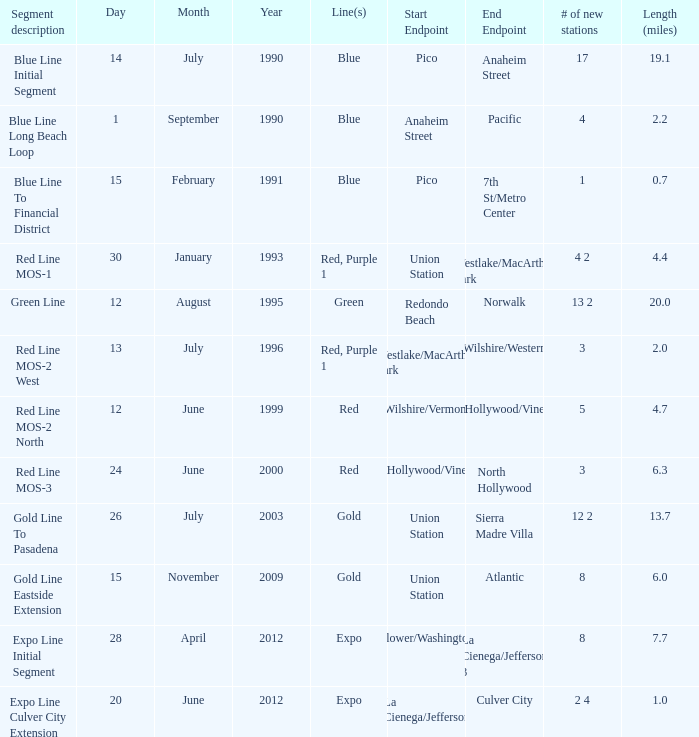What is the number of lines in the segment description of the red line mos-2 west? Red, Purple 1. 